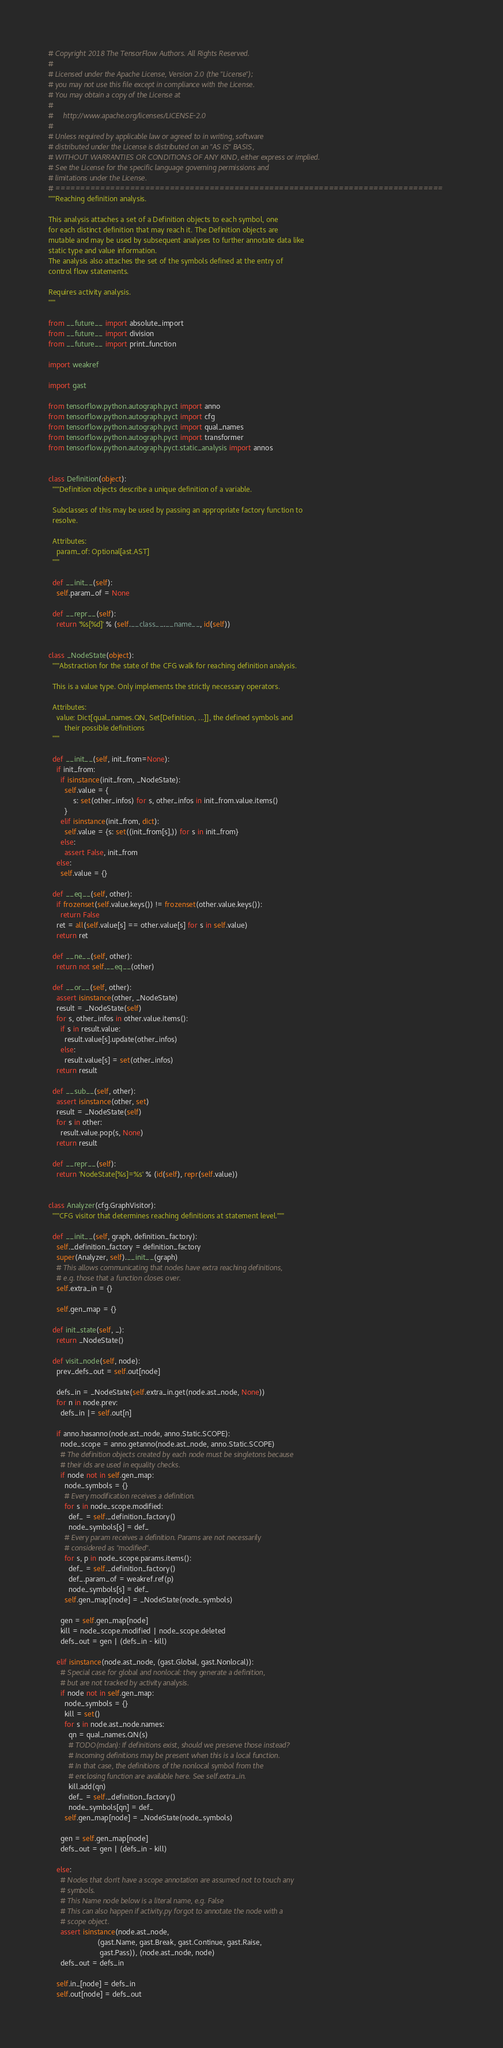<code> <loc_0><loc_0><loc_500><loc_500><_Python_># Copyright 2018 The TensorFlow Authors. All Rights Reserved.
#
# Licensed under the Apache License, Version 2.0 (the "License");
# you may not use this file except in compliance with the License.
# You may obtain a copy of the License at
#
#     http://www.apache.org/licenses/LICENSE-2.0
#
# Unless required by applicable law or agreed to in writing, software
# distributed under the License is distributed on an "AS IS" BASIS,
# WITHOUT WARRANTIES OR CONDITIONS OF ANY KIND, either express or implied.
# See the License for the specific language governing permissions and
# limitations under the License.
# ==============================================================================
"""Reaching definition analysis.

This analysis attaches a set of a Definition objects to each symbol, one
for each distinct definition that may reach it. The Definition objects are
mutable and may be used by subsequent analyses to further annotate data like
static type and value information.
The analysis also attaches the set of the symbols defined at the entry of
control flow statements.

Requires activity analysis.
"""

from __future__ import absolute_import
from __future__ import division
from __future__ import print_function

import weakref

import gast

from tensorflow.python.autograph.pyct import anno
from tensorflow.python.autograph.pyct import cfg
from tensorflow.python.autograph.pyct import qual_names
from tensorflow.python.autograph.pyct import transformer
from tensorflow.python.autograph.pyct.static_analysis import annos


class Definition(object):
  """Definition objects describe a unique definition of a variable.

  Subclasses of this may be used by passing an appropriate factory function to
  resolve.

  Attributes:
    param_of: Optional[ast.AST]
  """

  def __init__(self):
    self.param_of = None

  def __repr__(self):
    return '%s[%d]' % (self.__class__.__name__, id(self))


class _NodeState(object):
  """Abstraction for the state of the CFG walk for reaching definition analysis.

  This is a value type. Only implements the strictly necessary operators.

  Attributes:
    value: Dict[qual_names.QN, Set[Definition, ...]], the defined symbols and
        their possible definitions
  """

  def __init__(self, init_from=None):
    if init_from:
      if isinstance(init_from, _NodeState):
        self.value = {
            s: set(other_infos) for s, other_infos in init_from.value.items()
        }
      elif isinstance(init_from, dict):
        self.value = {s: set((init_from[s],)) for s in init_from}
      else:
        assert False, init_from
    else:
      self.value = {}

  def __eq__(self, other):
    if frozenset(self.value.keys()) != frozenset(other.value.keys()):
      return False
    ret = all(self.value[s] == other.value[s] for s in self.value)
    return ret

  def __ne__(self, other):
    return not self.__eq__(other)

  def __or__(self, other):
    assert isinstance(other, _NodeState)
    result = _NodeState(self)
    for s, other_infos in other.value.items():
      if s in result.value:
        result.value[s].update(other_infos)
      else:
        result.value[s] = set(other_infos)
    return result

  def __sub__(self, other):
    assert isinstance(other, set)
    result = _NodeState(self)
    for s in other:
      result.value.pop(s, None)
    return result

  def __repr__(self):
    return 'NodeState[%s]=%s' % (id(self), repr(self.value))


class Analyzer(cfg.GraphVisitor):
  """CFG visitor that determines reaching definitions at statement level."""

  def __init__(self, graph, definition_factory):
    self._definition_factory = definition_factory
    super(Analyzer, self).__init__(graph)
    # This allows communicating that nodes have extra reaching definitions,
    # e.g. those that a function closes over.
    self.extra_in = {}

    self.gen_map = {}

  def init_state(self, _):
    return _NodeState()

  def visit_node(self, node):
    prev_defs_out = self.out[node]

    defs_in = _NodeState(self.extra_in.get(node.ast_node, None))
    for n in node.prev:
      defs_in |= self.out[n]

    if anno.hasanno(node.ast_node, anno.Static.SCOPE):
      node_scope = anno.getanno(node.ast_node, anno.Static.SCOPE)
      # The definition objects created by each node must be singletons because
      # their ids are used in equality checks.
      if node not in self.gen_map:
        node_symbols = {}
        # Every modification receives a definition.
        for s in node_scope.modified:
          def_ = self._definition_factory()
          node_symbols[s] = def_
        # Every param receives a definition. Params are not necessarily
        # considered as "modified".
        for s, p in node_scope.params.items():
          def_ = self._definition_factory()
          def_.param_of = weakref.ref(p)
          node_symbols[s] = def_
        self.gen_map[node] = _NodeState(node_symbols)

      gen = self.gen_map[node]
      kill = node_scope.modified | node_scope.deleted
      defs_out = gen | (defs_in - kill)

    elif isinstance(node.ast_node, (gast.Global, gast.Nonlocal)):
      # Special case for global and nonlocal: they generate a definition,
      # but are not tracked by activity analysis.
      if node not in self.gen_map:
        node_symbols = {}
        kill = set()
        for s in node.ast_node.names:
          qn = qual_names.QN(s)
          # TODO(mdan): If definitions exist, should we preserve those instead?
          # Incoming definitions may be present when this is a local function.
          # In that case, the definitions of the nonlocal symbol from the
          # enclosing function are available here. See self.extra_in.
          kill.add(qn)
          def_ = self._definition_factory()
          node_symbols[qn] = def_
        self.gen_map[node] = _NodeState(node_symbols)

      gen = self.gen_map[node]
      defs_out = gen | (defs_in - kill)

    else:
      # Nodes that don't have a scope annotation are assumed not to touch any
      # symbols.
      # This Name node below is a literal name, e.g. False
      # This can also happen if activity.py forgot to annotate the node with a
      # scope object.
      assert isinstance(node.ast_node,
                        (gast.Name, gast.Break, gast.Continue, gast.Raise,
                         gast.Pass)), (node.ast_node, node)
      defs_out = defs_in

    self.in_[node] = defs_in
    self.out[node] = defs_out
</code> 